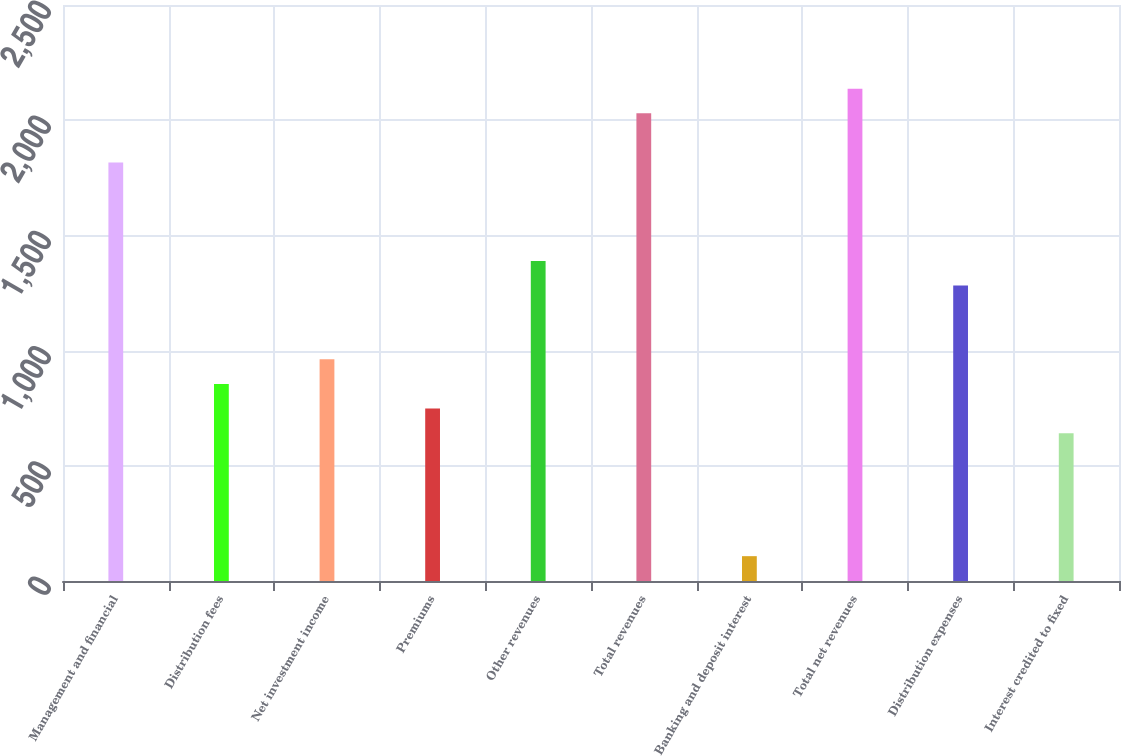Convert chart to OTSL. <chart><loc_0><loc_0><loc_500><loc_500><bar_chart><fcel>Management and financial<fcel>Distribution fees<fcel>Net investment income<fcel>Premiums<fcel>Other revenues<fcel>Total revenues<fcel>Banking and deposit interest<fcel>Total net revenues<fcel>Distribution expenses<fcel>Interest credited to fixed<nl><fcel>1816.6<fcel>855.4<fcel>962.2<fcel>748.6<fcel>1389.4<fcel>2030.2<fcel>107.8<fcel>2137<fcel>1282.6<fcel>641.8<nl></chart> 